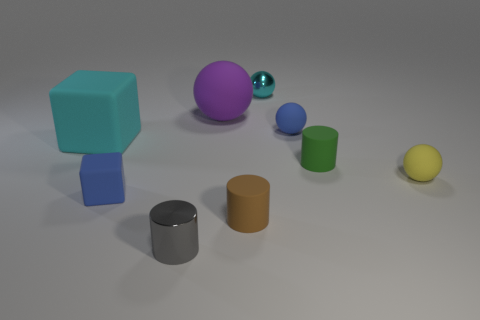There is a small object that is the same color as the small matte block; what is its material?
Make the answer very short. Rubber. There is a brown matte cylinder; is its size the same as the cyan object to the left of the small gray metal thing?
Provide a succinct answer. No. How many things are either yellow rubber things that are behind the tiny gray object or tiny metal things?
Give a very brief answer. 3. What shape is the large thing left of the big purple matte ball?
Your answer should be compact. Cube. Is the number of blue rubber things right of the brown thing the same as the number of tiny objects that are in front of the tiny cyan ball?
Ensure brevity in your answer.  No. What color is the small sphere that is behind the cyan cube and on the right side of the cyan metallic ball?
Ensure brevity in your answer.  Blue. There is a tiny thing to the left of the small cylinder that is on the left side of the tiny brown cylinder; what is its material?
Give a very brief answer. Rubber. Is the size of the blue rubber ball the same as the blue matte block?
Your answer should be compact. Yes. What number of big objects are blue matte blocks or cyan matte cubes?
Offer a very short reply. 1. There is a brown rubber cylinder; what number of small brown cylinders are to the left of it?
Give a very brief answer. 0. 